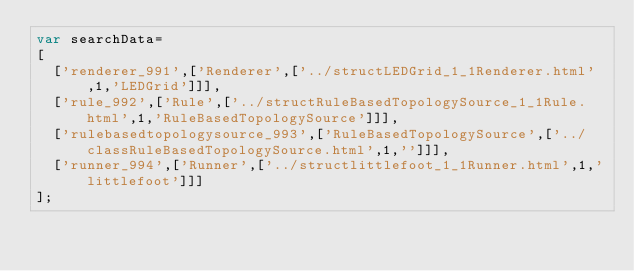<code> <loc_0><loc_0><loc_500><loc_500><_JavaScript_>var searchData=
[
  ['renderer_991',['Renderer',['../structLEDGrid_1_1Renderer.html',1,'LEDGrid']]],
  ['rule_992',['Rule',['../structRuleBasedTopologySource_1_1Rule.html',1,'RuleBasedTopologySource']]],
  ['rulebasedtopologysource_993',['RuleBasedTopologySource',['../classRuleBasedTopologySource.html',1,'']]],
  ['runner_994',['Runner',['../structlittlefoot_1_1Runner.html',1,'littlefoot']]]
];
</code> 